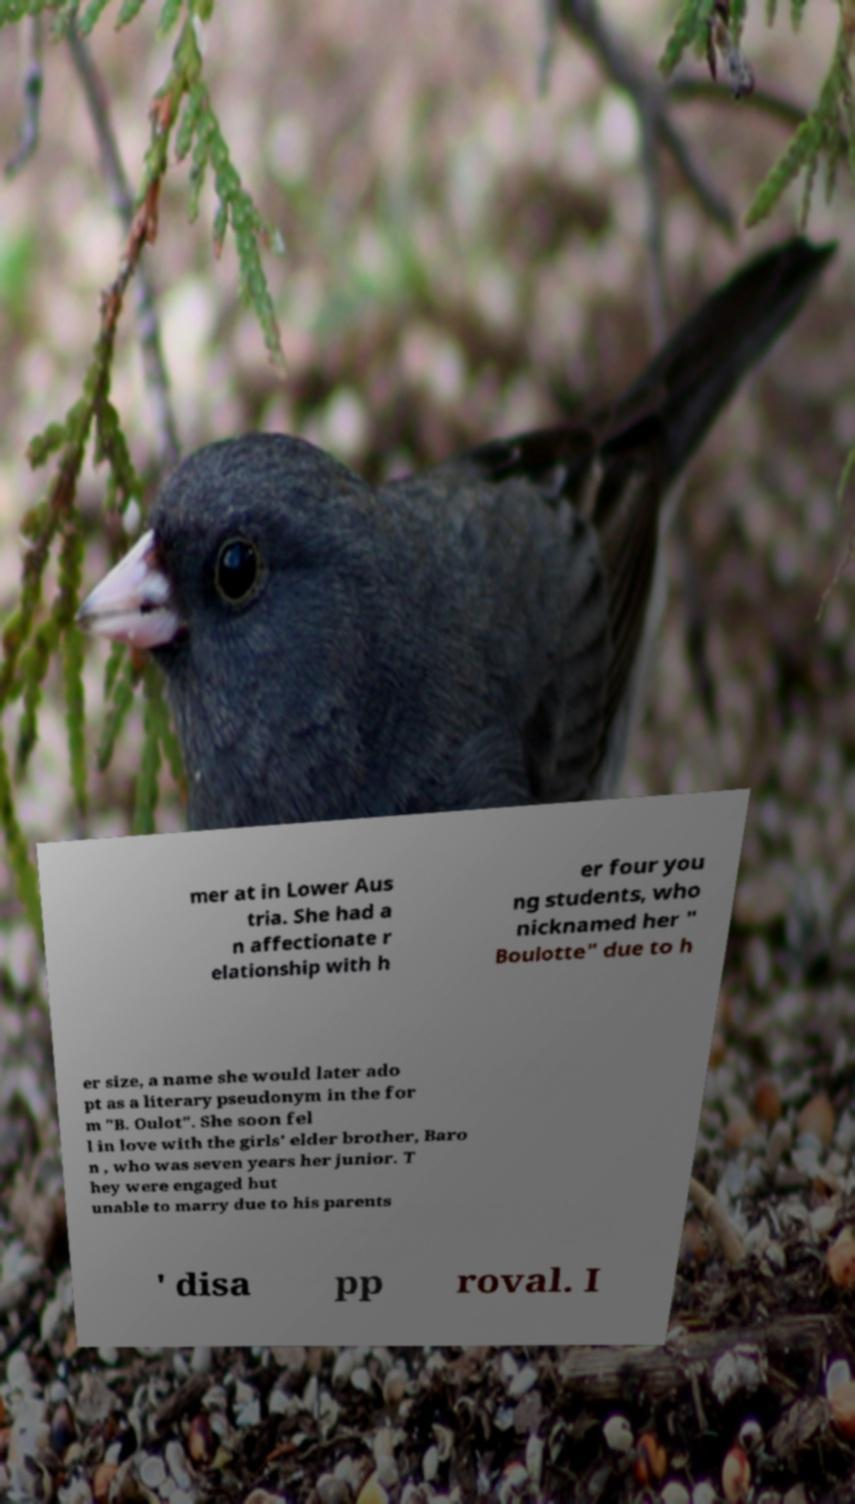What messages or text are displayed in this image? I need them in a readable, typed format. mer at in Lower Aus tria. She had a n affectionate r elationship with h er four you ng students, who nicknamed her " Boulotte" due to h er size, a name she would later ado pt as a literary pseudonym in the for m "B. Oulot". She soon fel l in love with the girls' elder brother, Baro n , who was seven years her junior. T hey were engaged but unable to marry due to his parents ' disa pp roval. I 